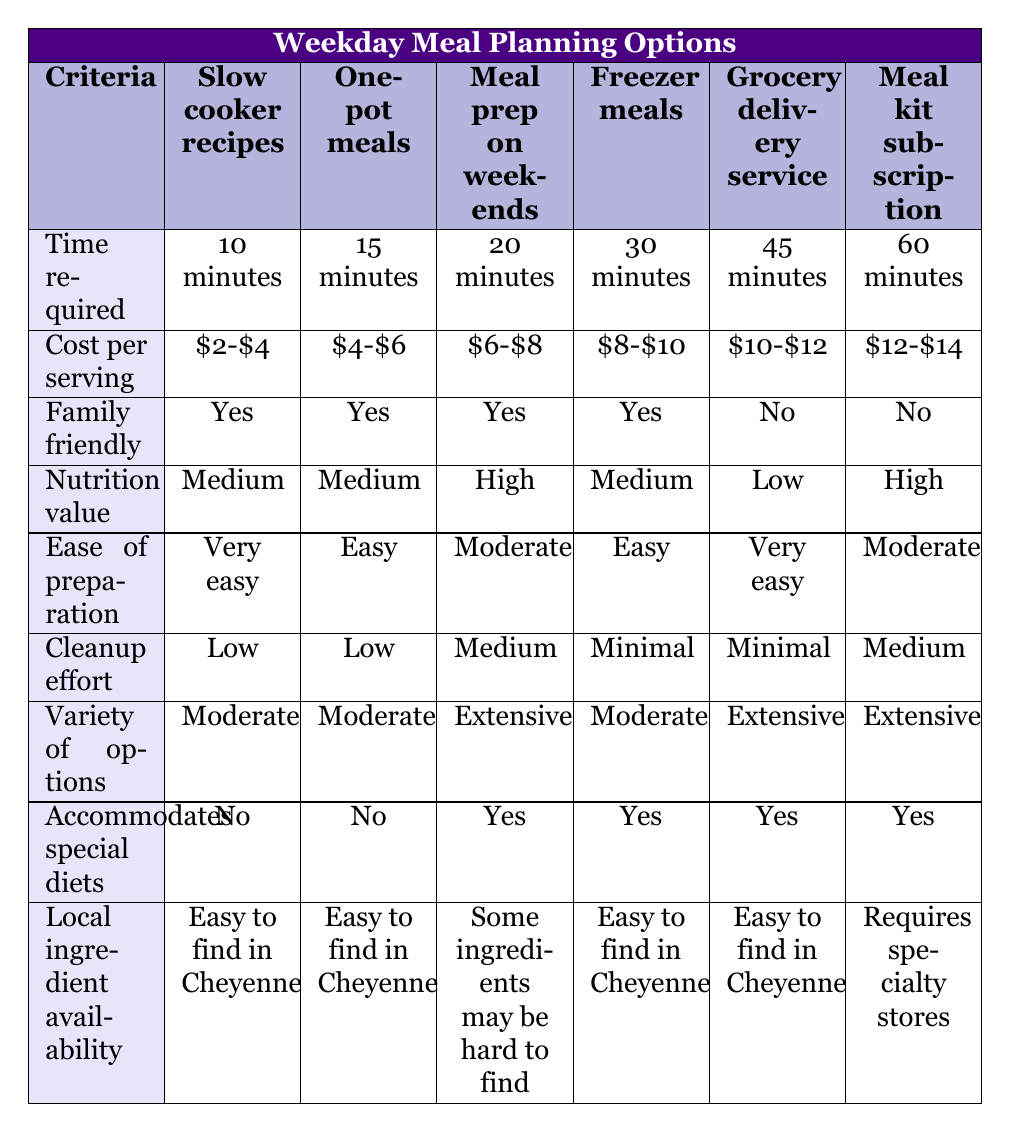What is the time required for meal prep on weekends? The table indicates that meal prep on weekends requires 20 minutes. You can directly find this information in the corresponding row under the "Time required" column.
Answer: 20 minutes Which options are family-friendly? The family-friendly options can be identified by checking the "Family friendly" column for "Yes." The options that match this criterion are slow cooker recipes, one-pot meals, and meal prep on weekends.
Answer: Slow cooker recipes, one-pot meals, meal prep on weekends What is the cost per serving of freezer meals? The table lists that the cost per serving for freezer meals is between $8 and $10. This is directly found in the "Cost per serving" column under the freezer meals row.
Answer: $8-$10 How many meal options accommodate special diets? To find the options that accommodate special diets, check the "Accommodates special diets" column for "Yes." The options that meet this condition are meal prep on weekends, freezer meals, grocery delivery service, and meal kit subscription. There are four options in total.
Answer: 4 Which meal option requires the least cleanup effort and what is that effort level? The table shows cleanup effort levels, and the least cleanup effort is categorized as "Minimal." This is applicable to freezer meals and grocery delivery service. These options can be found by looking at the "Cleanup effort" row.
Answer: Freezer meals and grocery delivery service, Minimal What is the average cost per serving of all listed meal options? The cost per serving can be converted as follows: ($2 + $4 + $4 + $6 + $8 + $10 + $10 + $12 + $12 + $14) / 6 = $9. Thus, the sum of the average values presents a neat way to calculate the average using brackets.
Answer: $8-$10 (considering rounding to approximate cost ranges) Which meal options have high nutrition value? By looking at the "Nutrition value" column, we find that the meal prep on weekends and meal kit subscription are the only options listed as having high nutrition value.
Answer: Meal prep on weekends, meal kit subscription How many meal options are easy to prepare? By checking the "Ease of preparation" row for the label "Easy," the one-pot meals and freezer meals qualify as easy options, yielding a total of two meal options that are easy to prepare.
Answer: 2 Which meal option has extensive variety but does not accommodate special diets? To ascertain the meal option with extensive variety that does not accommodate special diets, we look in the "Variety of options" column. The one-pot meals meet this criterion as they are categorized as extensive but have "No" under the special diets column.
Answer: One-pot meals 